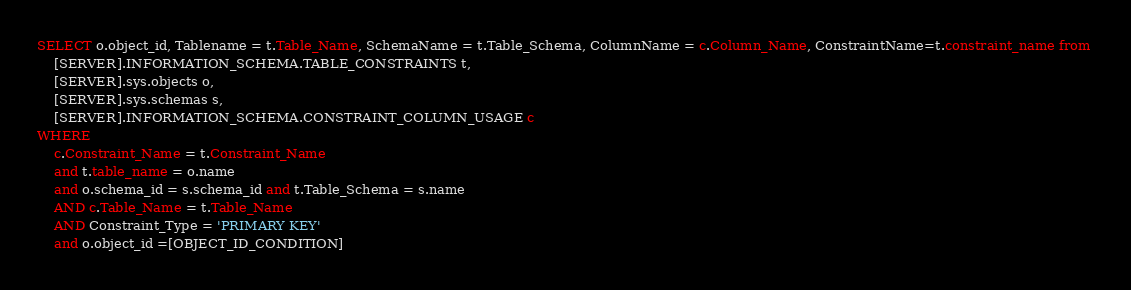<code> <loc_0><loc_0><loc_500><loc_500><_SQL_>SELECT o.object_id, Tablename = t.Table_Name, SchemaName = t.Table_Schema, ColumnName = c.Column_Name, ConstraintName=t.constraint_name from 
    [SERVER].INFORMATION_SCHEMA.TABLE_CONSTRAINTS t,
    [SERVER].sys.objects o,
    [SERVER].sys.schemas s,
    [SERVER].INFORMATION_SCHEMA.CONSTRAINT_COLUMN_USAGE c
WHERE 
    c.Constraint_Name = t.Constraint_Name
    and t.table_name = o.name 
    and o.schema_id = s.schema_id and t.Table_Schema = s.name
    AND c.Table_Name = t.Table_Name
    AND Constraint_Type = 'PRIMARY KEY'
	and o.object_id =[OBJECT_ID_CONDITION]
</code> 